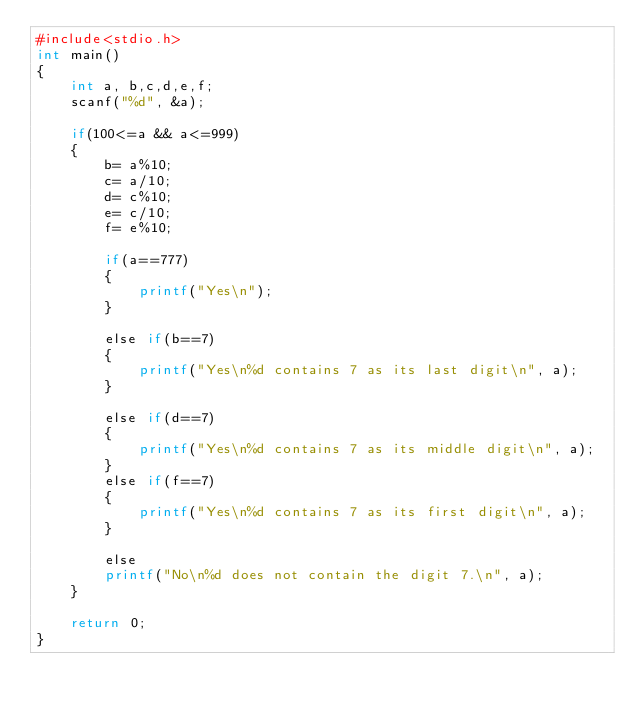<code> <loc_0><loc_0><loc_500><loc_500><_Awk_>#include<stdio.h>
int main()
{
    int a, b,c,d,e,f;
    scanf("%d", &a);

    if(100<=a && a<=999)
    {
        b= a%10;
        c= a/10;
        d= c%10;
        e= c/10;
        f= e%10;

        if(a==777)
        {
            printf("Yes\n");
        }

        else if(b==7)
        {
            printf("Yes\n%d contains 7 as its last digit\n", a);
        }

        else if(d==7)
        {
            printf("Yes\n%d contains 7 as its middle digit\n", a);
        }
        else if(f==7)
        {
            printf("Yes\n%d contains 7 as its first digit\n", a);
        }

        else
        printf("No\n%d does not contain the digit 7.\n", a);
    }

    return 0;
}
</code> 